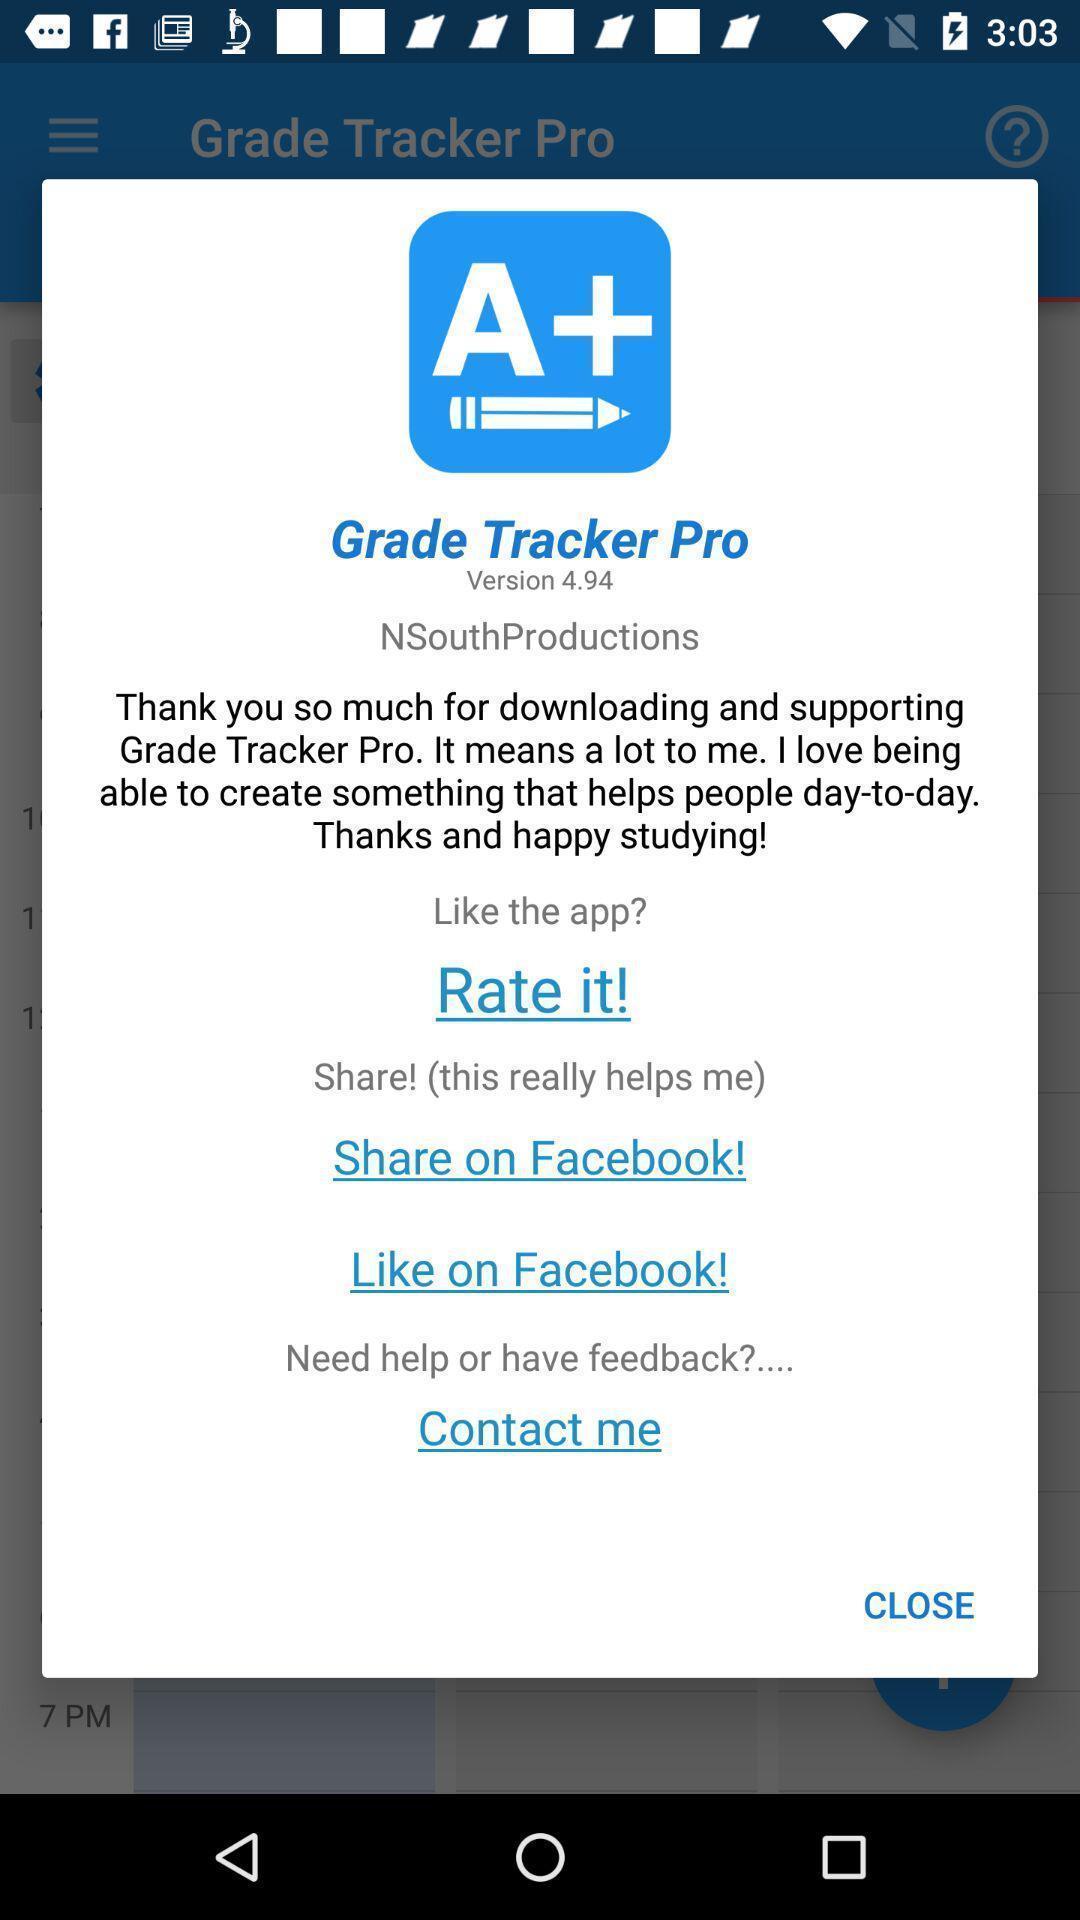Describe the visual elements of this screenshot. Pop-up displaying thanking message for downloading app. 